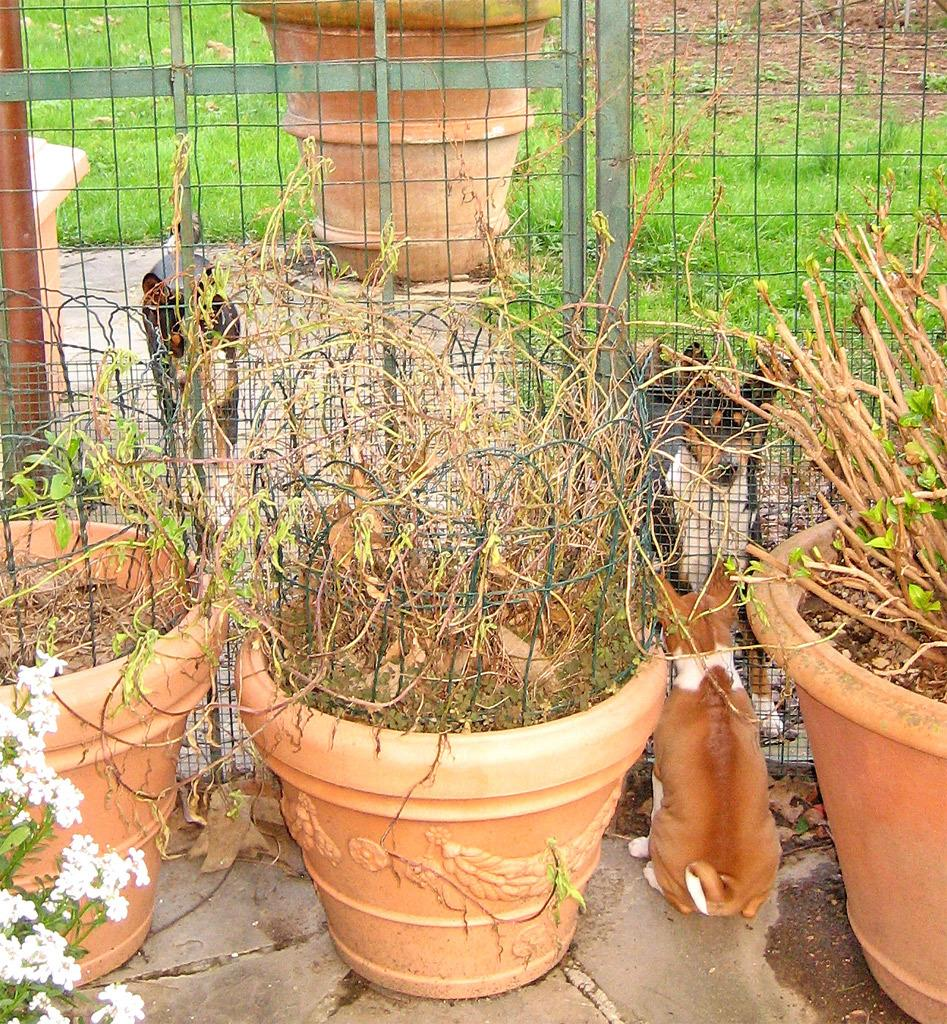What type of animals are in the image? There are dogs in the image. Where are some of the dogs located in the image? Some dogs are on the left side of the image. What type of vegetation is present in the image? There are plants and grass in the image. What type of rake is being used by the dogs in the image? There is no rake present in the image; the dogs are not using any tools. 